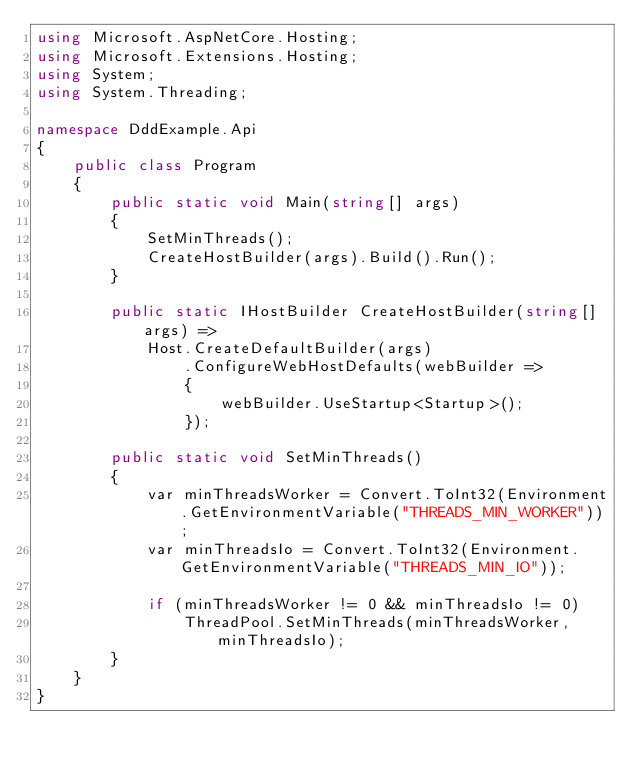<code> <loc_0><loc_0><loc_500><loc_500><_C#_>using Microsoft.AspNetCore.Hosting;
using Microsoft.Extensions.Hosting;
using System;
using System.Threading;

namespace DddExample.Api
{
    public class Program
    {
        public static void Main(string[] args)
        {
            SetMinThreads();
            CreateHostBuilder(args).Build().Run();
        }

        public static IHostBuilder CreateHostBuilder(string[] args) =>
            Host.CreateDefaultBuilder(args)
                .ConfigureWebHostDefaults(webBuilder =>
                {
                    webBuilder.UseStartup<Startup>();
                });

        public static void SetMinThreads()
        {
            var minThreadsWorker = Convert.ToInt32(Environment.GetEnvironmentVariable("THREADS_MIN_WORKER"));
            var minThreadsIo = Convert.ToInt32(Environment.GetEnvironmentVariable("THREADS_MIN_IO"));

            if (minThreadsWorker != 0 && minThreadsIo != 0)
                ThreadPool.SetMinThreads(minThreadsWorker, minThreadsIo);
        }
    }
}
</code> 